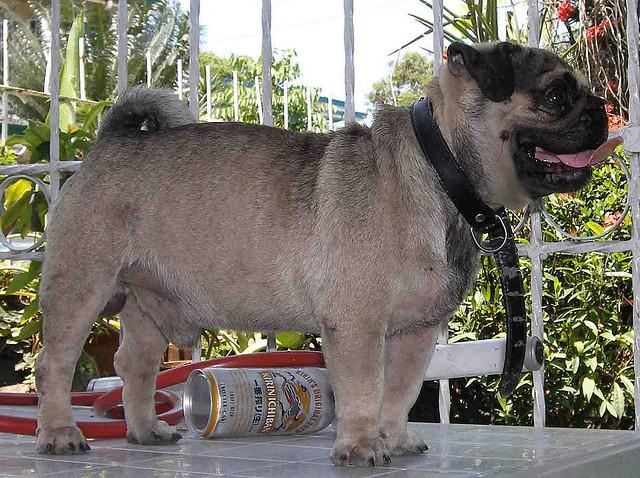What is in the can?
Be succinct. Beer. What is this dog wearing?
Short answer required. Collar. Is the dog wearing a collar?
Short answer required. Yes. 